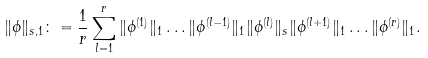Convert formula to latex. <formula><loc_0><loc_0><loc_500><loc_500>\| \phi \| _ { s , 1 } & \colon = \frac { 1 } { r } \sum _ { l = 1 } ^ { r } \| \phi ^ { ( 1 ) } \| _ { 1 } \dots \| \phi ^ { ( l - 1 ) } \| _ { 1 } \| \phi ^ { ( l ) } \| _ { s } \| \phi ^ { ( l + 1 ) } \| _ { 1 } \dots \| \phi ^ { ( r ) } \| _ { 1 } .</formula> 